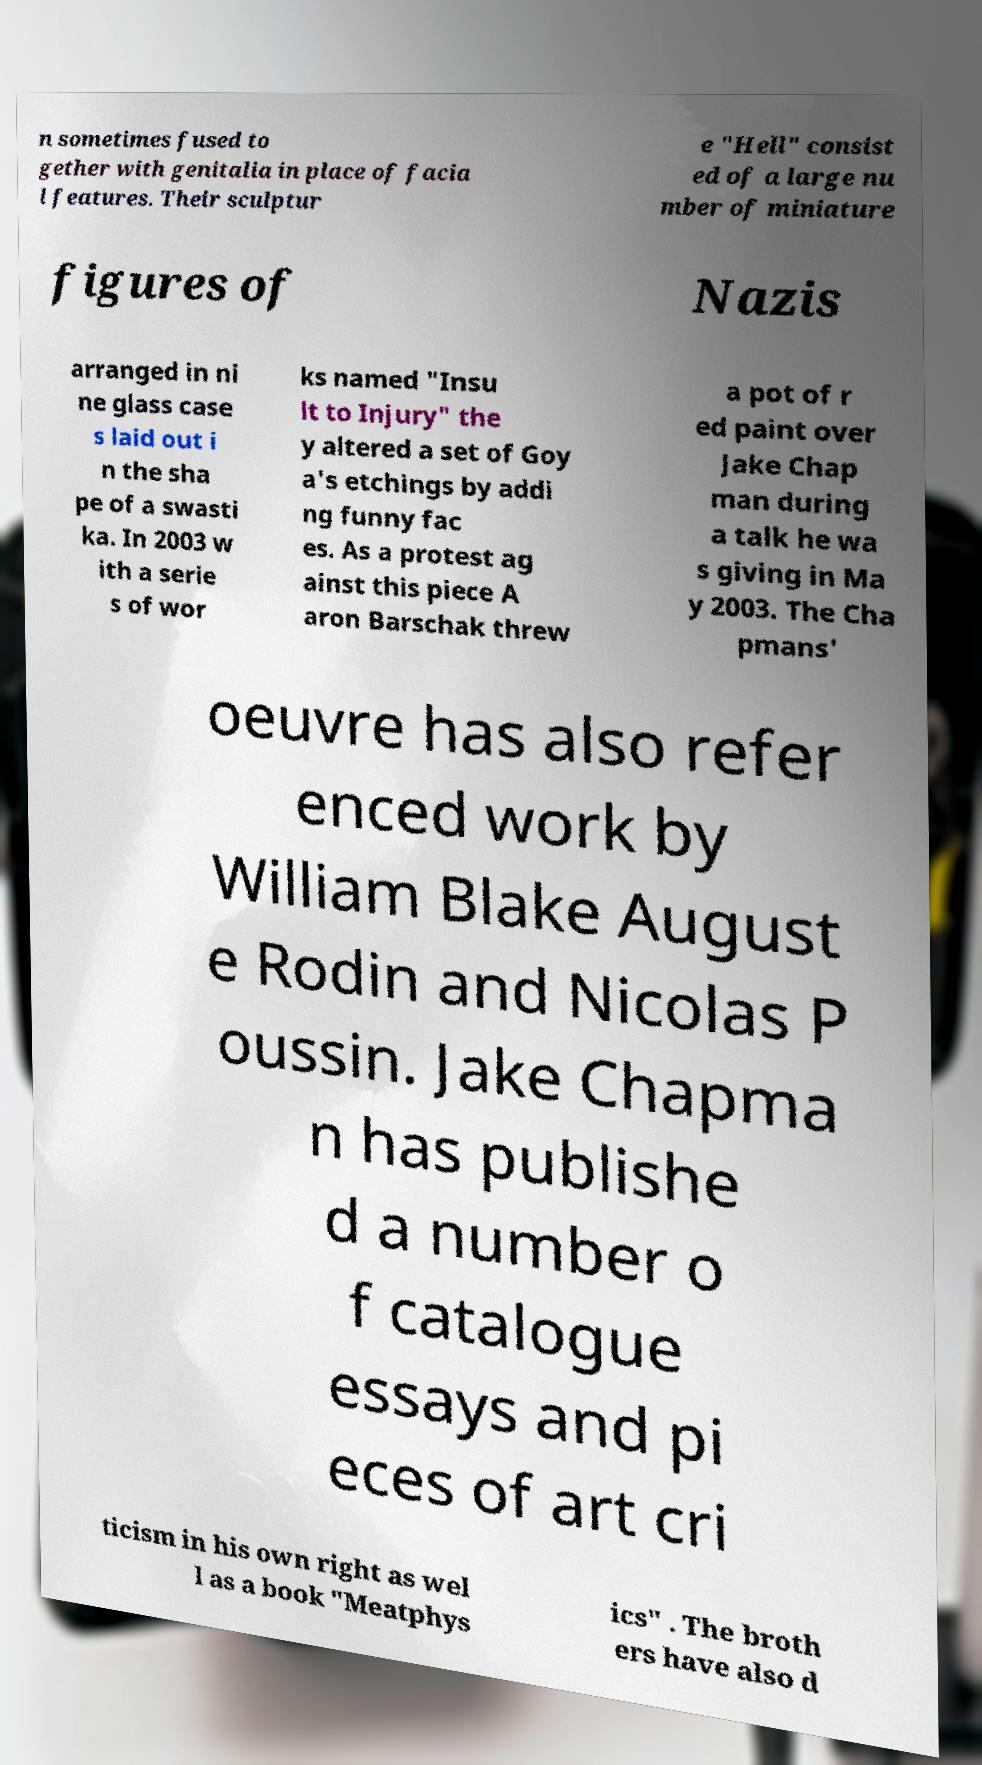Please read and relay the text visible in this image. What does it say? n sometimes fused to gether with genitalia in place of facia l features. Their sculptur e "Hell" consist ed of a large nu mber of miniature figures of Nazis arranged in ni ne glass case s laid out i n the sha pe of a swasti ka. In 2003 w ith a serie s of wor ks named "Insu lt to Injury" the y altered a set of Goy a's etchings by addi ng funny fac es. As a protest ag ainst this piece A aron Barschak threw a pot of r ed paint over Jake Chap man during a talk he wa s giving in Ma y 2003. The Cha pmans' oeuvre has also refer enced work by William Blake August e Rodin and Nicolas P oussin. Jake Chapma n has publishe d a number o f catalogue essays and pi eces of art cri ticism in his own right as wel l as a book "Meatphys ics" . The broth ers have also d 